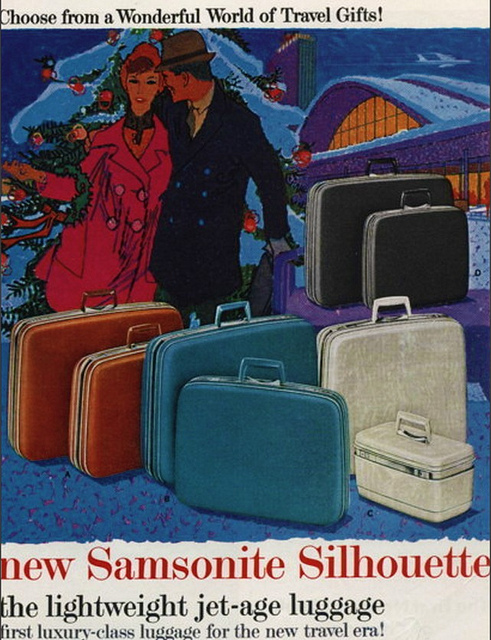What era does the advertisement seem to be from? The vintage style of the artwork, fashion, and emphasis on 'jet-age' travel suggests that the advertisement likely originates from the mid-20th century, reflecting the glamour and optimism of the time. 